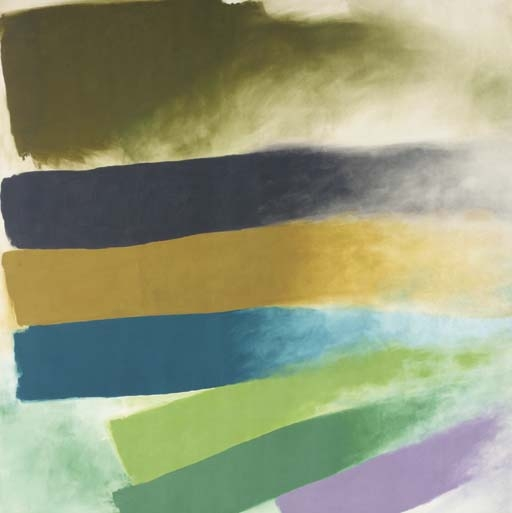What emotions does this painting evoke? The painting's broad strokes and choice of colors can evoke a range of emotions from calmness and serenity, due to the cooler tones of blue and green, to a sense of warmth and optimism brought forth by the bold yellow. The layering effect might also suggest depth, akin to peering through mist, adding a touch of mystery or introspection. 